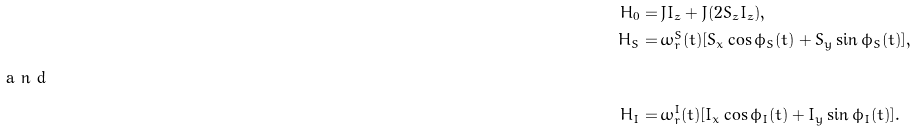Convert formula to latex. <formula><loc_0><loc_0><loc_500><loc_500>H _ { 0 } = \, & J I _ { z } + J ( 2 S _ { z } I _ { z } ) , \\ H _ { S } = \, & \omega _ { r } ^ { S } ( t ) [ S _ { x } \cos \phi _ { S } ( t ) + S _ { y } \sin \phi _ { S } ( t ) ] , \\ \intertext { a n d } H _ { I } = \, & \omega _ { r } ^ { I } ( t ) [ I _ { x } \cos \phi _ { I } ( t ) + I _ { y } \sin \phi _ { I } ( t ) ] .</formula> 